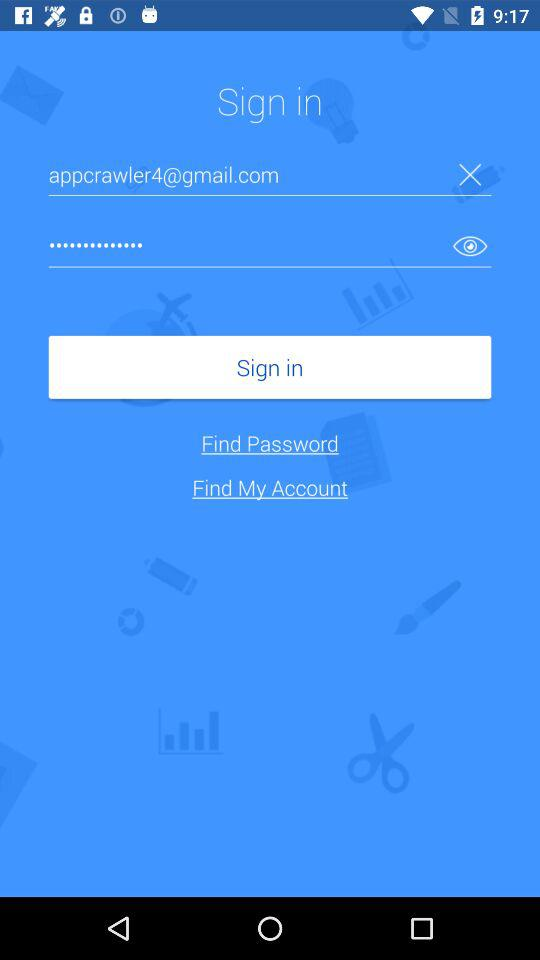What is the email address? The email address is appcrawler4@gmail.com. 